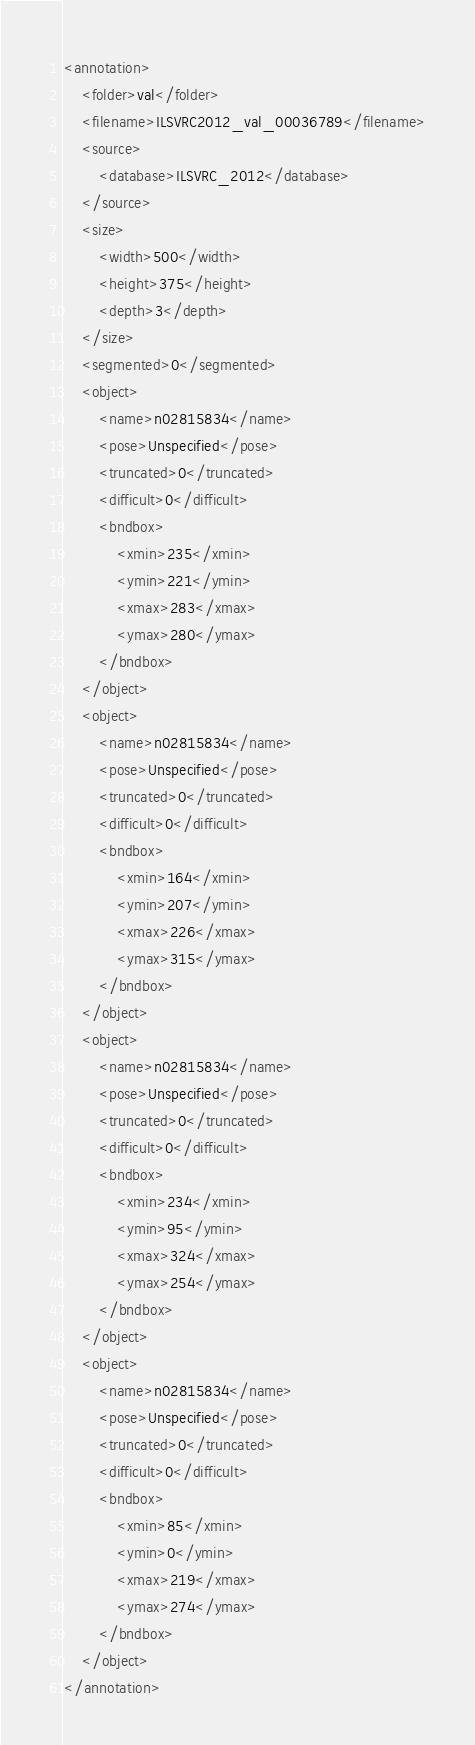Convert code to text. <code><loc_0><loc_0><loc_500><loc_500><_XML_><annotation>
	<folder>val</folder>
	<filename>ILSVRC2012_val_00036789</filename>
	<source>
		<database>ILSVRC_2012</database>
	</source>
	<size>
		<width>500</width>
		<height>375</height>
		<depth>3</depth>
	</size>
	<segmented>0</segmented>
	<object>
		<name>n02815834</name>
		<pose>Unspecified</pose>
		<truncated>0</truncated>
		<difficult>0</difficult>
		<bndbox>
			<xmin>235</xmin>
			<ymin>221</ymin>
			<xmax>283</xmax>
			<ymax>280</ymax>
		</bndbox>
	</object>
	<object>
		<name>n02815834</name>
		<pose>Unspecified</pose>
		<truncated>0</truncated>
		<difficult>0</difficult>
		<bndbox>
			<xmin>164</xmin>
			<ymin>207</ymin>
			<xmax>226</xmax>
			<ymax>315</ymax>
		</bndbox>
	</object>
	<object>
		<name>n02815834</name>
		<pose>Unspecified</pose>
		<truncated>0</truncated>
		<difficult>0</difficult>
		<bndbox>
			<xmin>234</xmin>
			<ymin>95</ymin>
			<xmax>324</xmax>
			<ymax>254</ymax>
		</bndbox>
	</object>
	<object>
		<name>n02815834</name>
		<pose>Unspecified</pose>
		<truncated>0</truncated>
		<difficult>0</difficult>
		<bndbox>
			<xmin>85</xmin>
			<ymin>0</ymin>
			<xmax>219</xmax>
			<ymax>274</ymax>
		</bndbox>
	</object>
</annotation></code> 